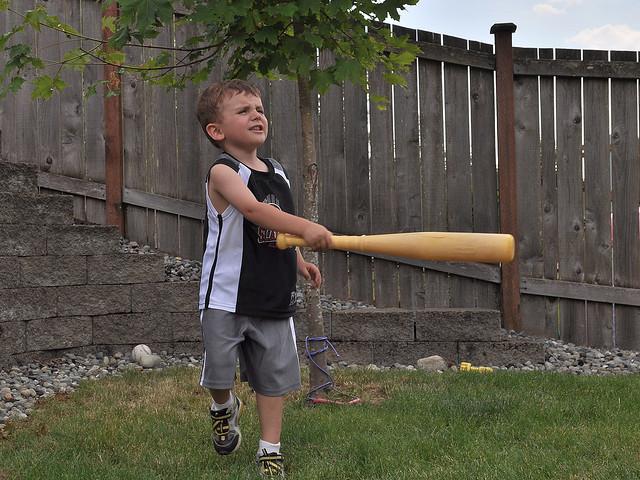How many children are there?
Be succinct. 1. Is this fence built on level ground?
Quick response, please. No. Where are they?
Concise answer only. Backyard. Where is the baseball?
Answer briefly. Behind boy. What is the boy holding in his hand?
Be succinct. Bat. 